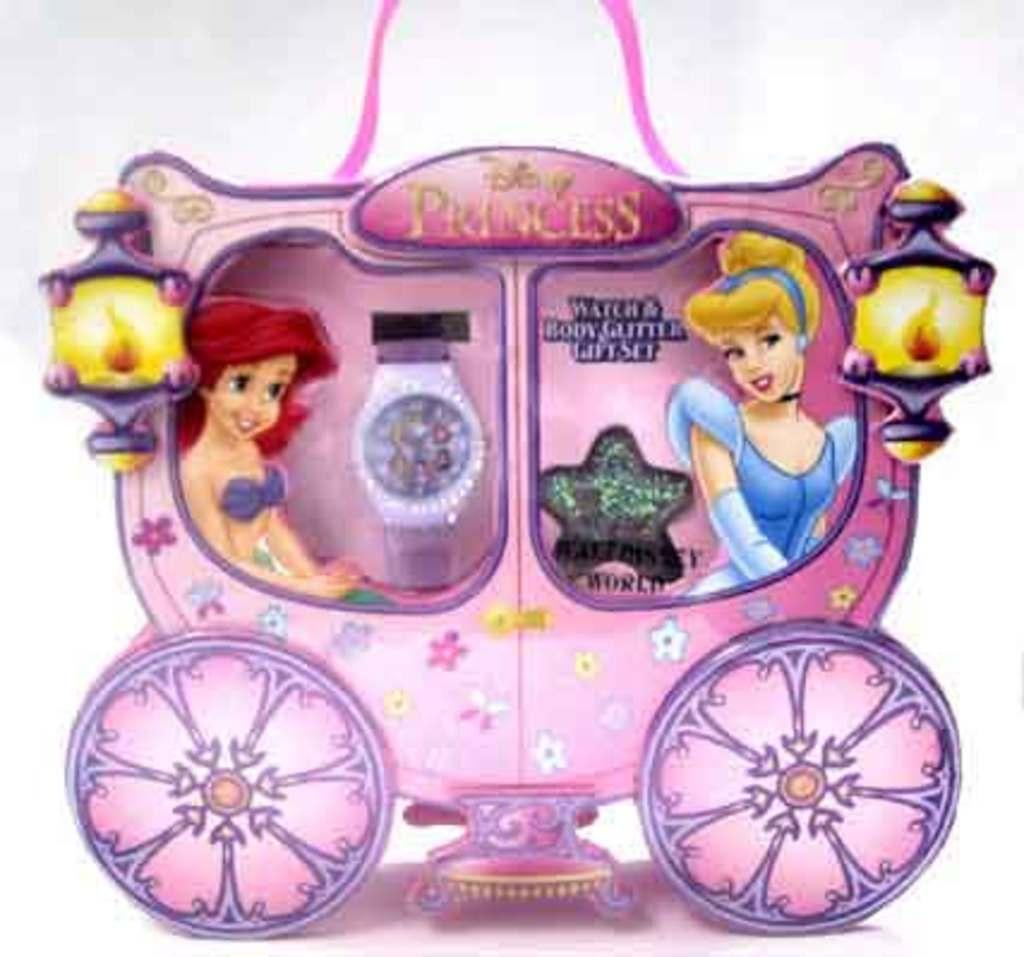<image>
Render a clear and concise summary of the photo. A coach that says Disney Princess on it with Ariel and Cinderella in it. 